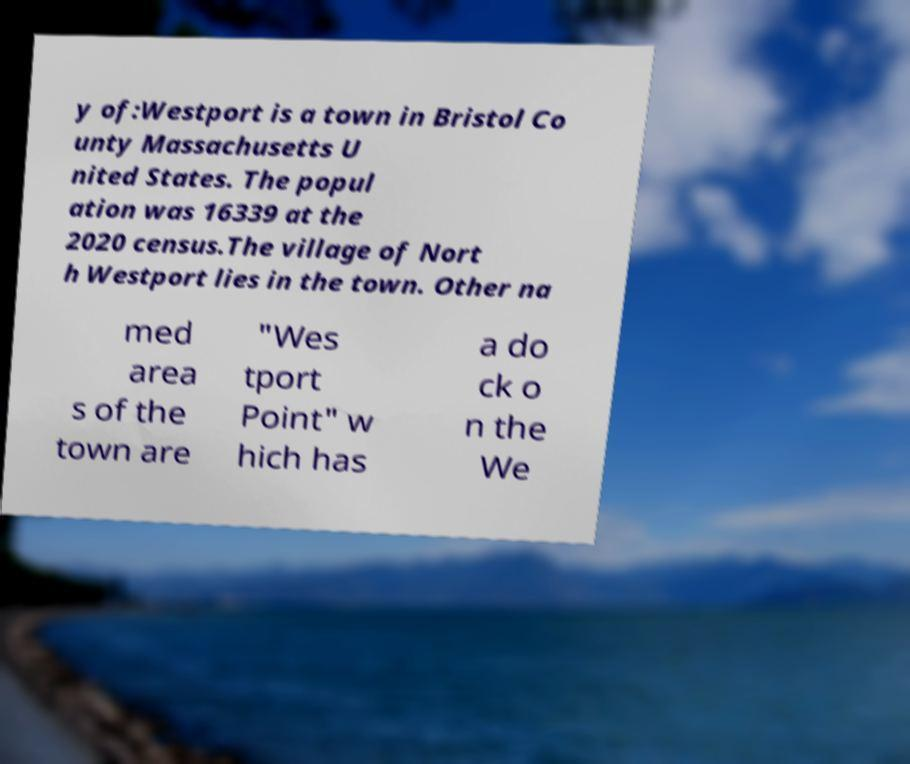Could you extract and type out the text from this image? y of:Westport is a town in Bristol Co unty Massachusetts U nited States. The popul ation was 16339 at the 2020 census.The village of Nort h Westport lies in the town. Other na med area s of the town are "Wes tport Point" w hich has a do ck o n the We 